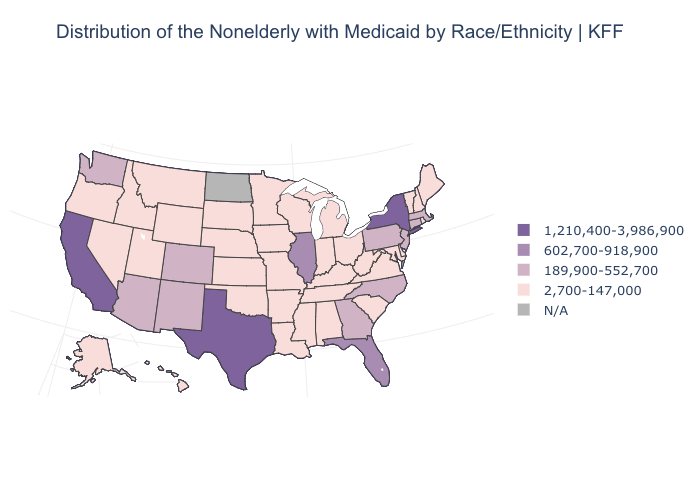Does Texas have the highest value in the USA?
Be succinct. Yes. Which states have the highest value in the USA?
Concise answer only. California, New York, Texas. What is the value of Alaska?
Write a very short answer. 2,700-147,000. Name the states that have a value in the range N/A?
Keep it brief. North Dakota. What is the value of Nebraska?
Quick response, please. 2,700-147,000. What is the highest value in the USA?
Quick response, please. 1,210,400-3,986,900. Which states have the lowest value in the West?
Concise answer only. Alaska, Hawaii, Idaho, Montana, Nevada, Oregon, Utah, Wyoming. Name the states that have a value in the range 1,210,400-3,986,900?
Answer briefly. California, New York, Texas. What is the value of Massachusetts?
Keep it brief. 189,900-552,700. What is the value of Florida?
Give a very brief answer. 602,700-918,900. Among the states that border Arkansas , does Texas have the lowest value?
Concise answer only. No. Among the states that border Nevada , does California have the lowest value?
Concise answer only. No. What is the value of Colorado?
Write a very short answer. 189,900-552,700. Among the states that border Wisconsin , does Iowa have the lowest value?
Keep it brief. Yes. 